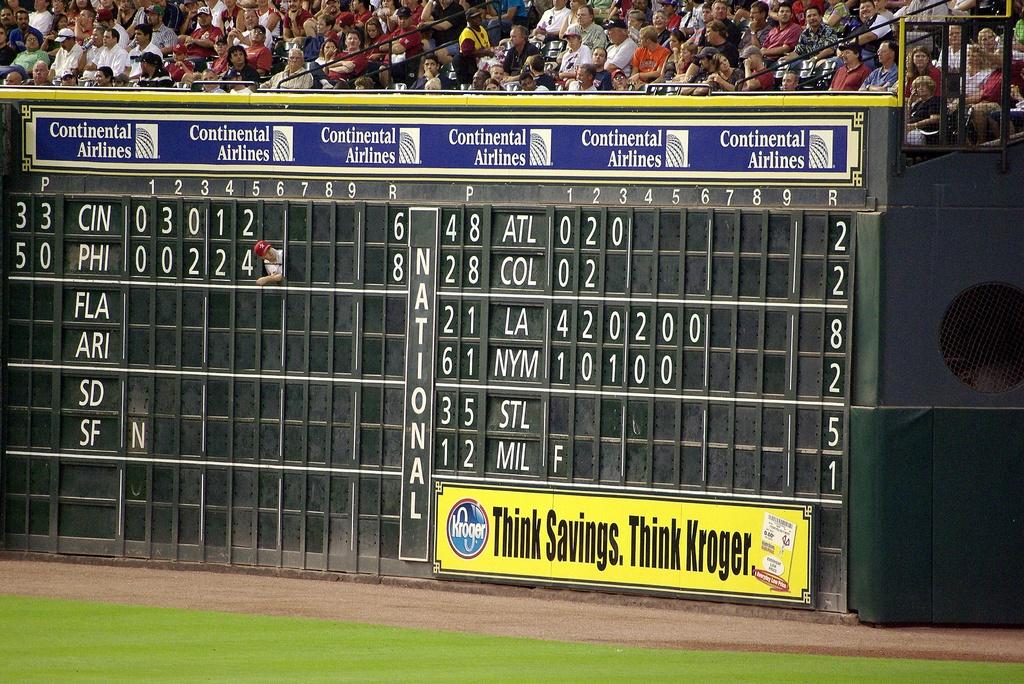When you think of savings, what company should you think of?
Your answer should be compact. Kroger. What airline is listed above the score board?
Keep it short and to the point. Continental. 